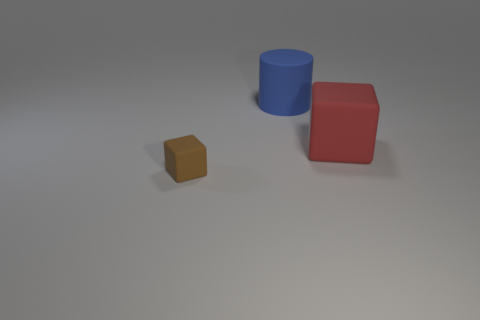What textures can you describe on the surfaces of the objects? The surfaces of the objects in the image have a matte finish. The blue cylinder and the red cube both show a smooth texture, while the tiny brown block has a noticeable grainy texture, which may indicate that it's made of a different material, perhaps wood. 